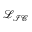Convert formula to latex. <formula><loc_0><loc_0><loc_500><loc_500>\mathcal { L } _ { \mathcal { I C } }</formula> 